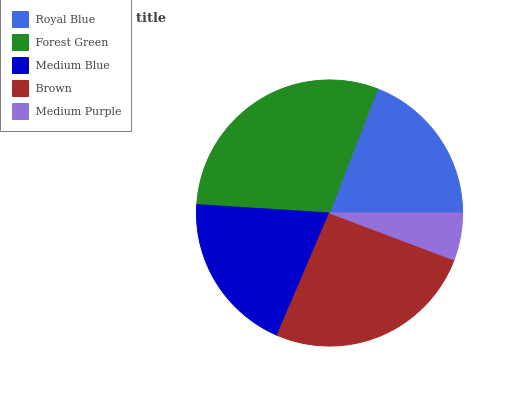Is Medium Purple the minimum?
Answer yes or no. Yes. Is Forest Green the maximum?
Answer yes or no. Yes. Is Medium Blue the minimum?
Answer yes or no. No. Is Medium Blue the maximum?
Answer yes or no. No. Is Forest Green greater than Medium Blue?
Answer yes or no. Yes. Is Medium Blue less than Forest Green?
Answer yes or no. Yes. Is Medium Blue greater than Forest Green?
Answer yes or no. No. Is Forest Green less than Medium Blue?
Answer yes or no. No. Is Medium Blue the high median?
Answer yes or no. Yes. Is Medium Blue the low median?
Answer yes or no. Yes. Is Forest Green the high median?
Answer yes or no. No. Is Forest Green the low median?
Answer yes or no. No. 